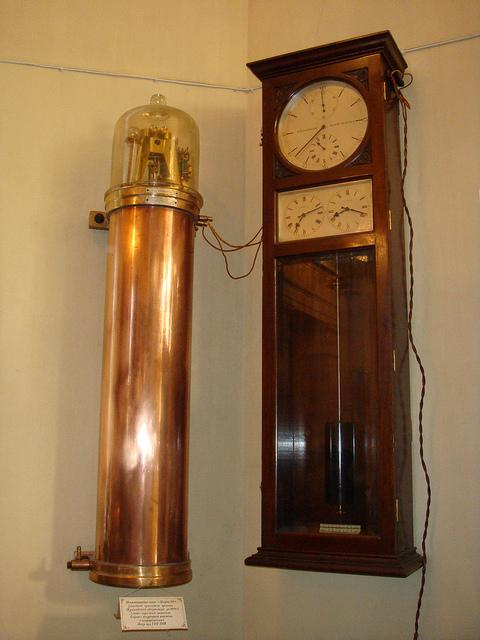What is connected to the long cylinder? clock 